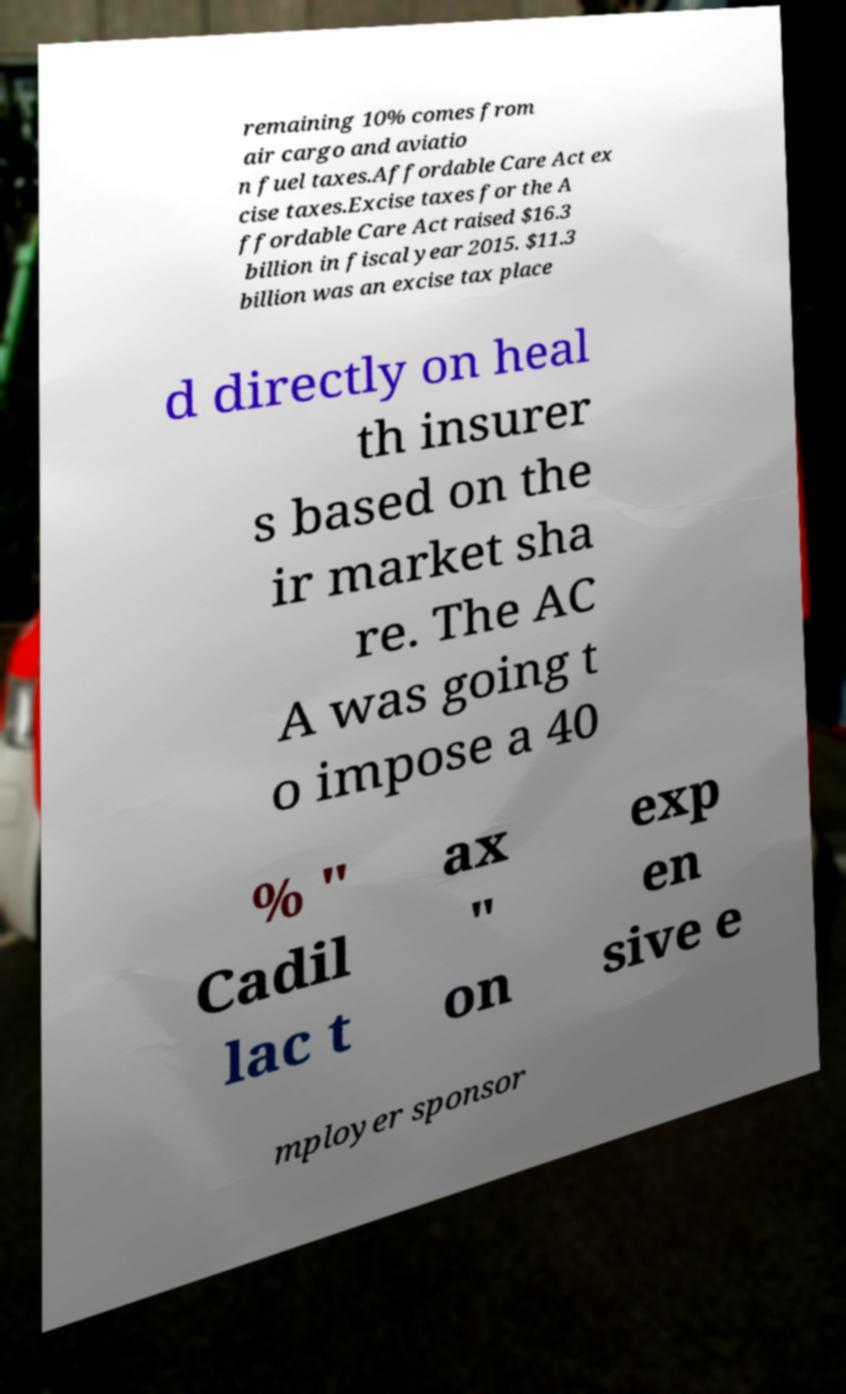Please identify and transcribe the text found in this image. remaining 10% comes from air cargo and aviatio n fuel taxes.Affordable Care Act ex cise taxes.Excise taxes for the A ffordable Care Act raised $16.3 billion in fiscal year 2015. $11.3 billion was an excise tax place d directly on heal th insurer s based on the ir market sha re. The AC A was going t o impose a 40 % " Cadil lac t ax " on exp en sive e mployer sponsor 